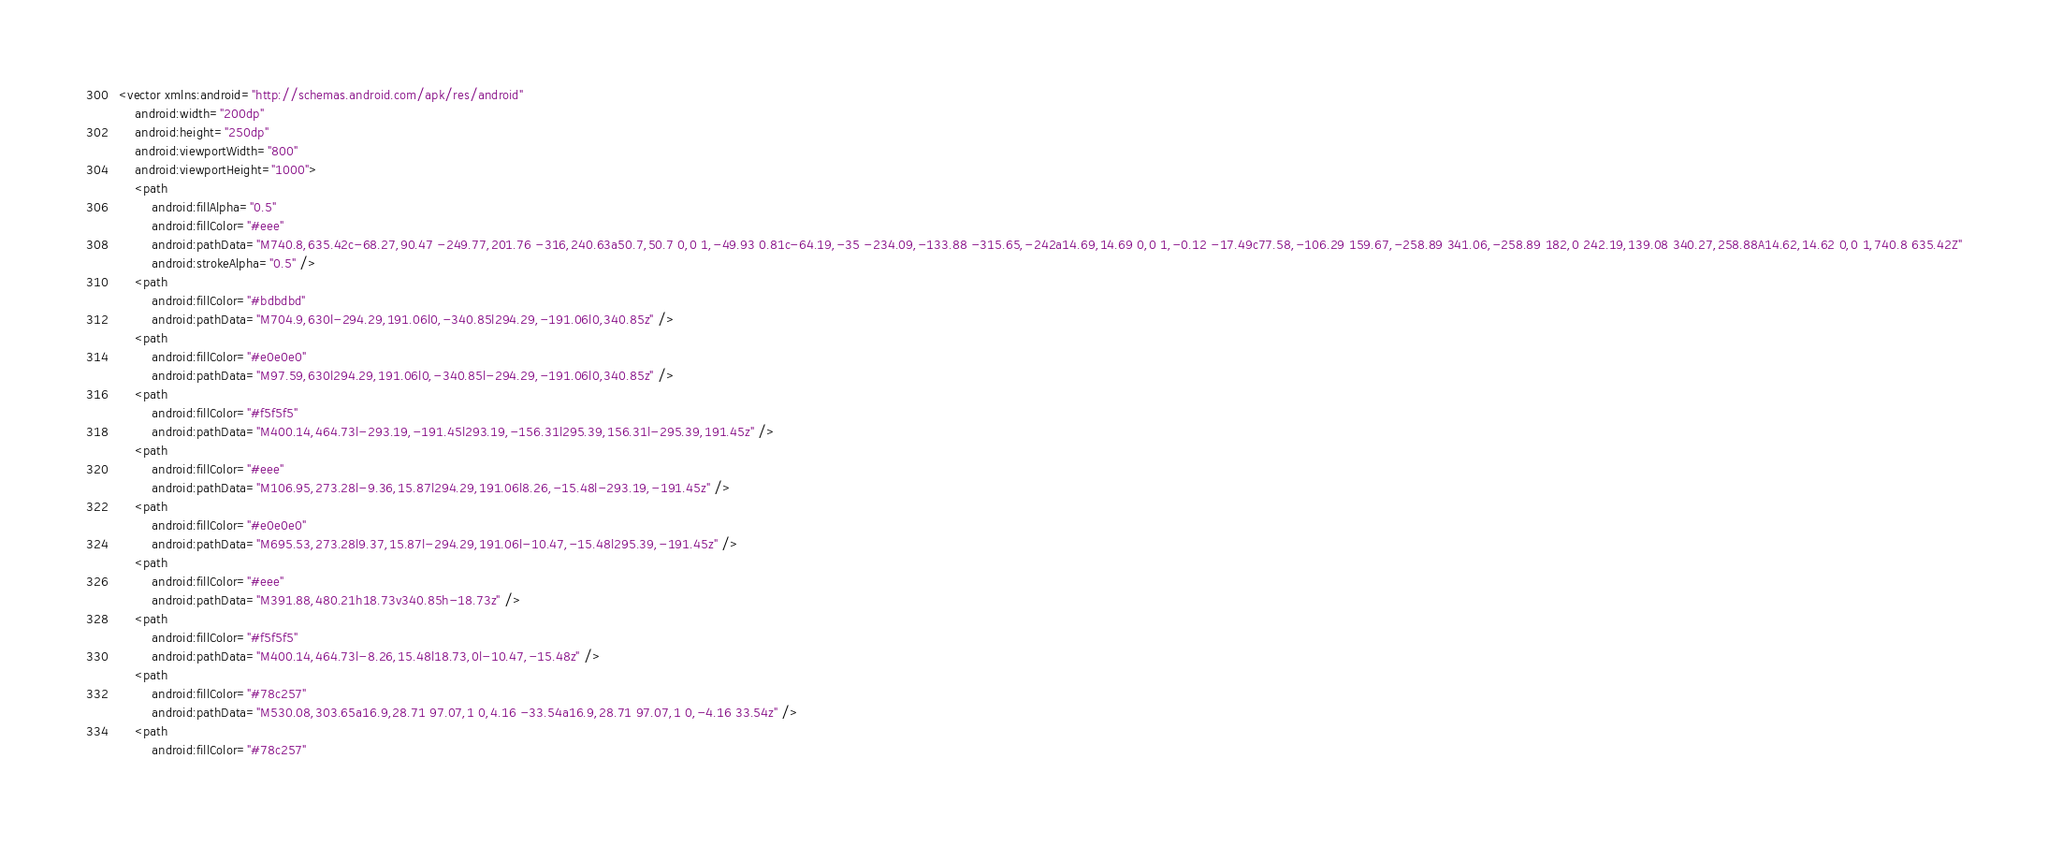<code> <loc_0><loc_0><loc_500><loc_500><_XML_>
<vector xmlns:android="http://schemas.android.com/apk/res/android"
    android:width="200dp"
    android:height="250dp"
    android:viewportWidth="800"
    android:viewportHeight="1000">
    <path
        android:fillAlpha="0.5"
        android:fillColor="#eee"
        android:pathData="M740.8,635.42c-68.27,90.47 -249.77,201.76 -316,240.63a50.7,50.7 0,0 1,-49.93 0.81c-64.19,-35 -234.09,-133.88 -315.65,-242a14.69,14.69 0,0 1,-0.12 -17.49c77.58,-106.29 159.67,-258.89 341.06,-258.89 182,0 242.19,139.08 340.27,258.88A14.62,14.62 0,0 1,740.8 635.42Z"
        android:strokeAlpha="0.5" />
    <path
        android:fillColor="#bdbdbd"
        android:pathData="M704.9,630l-294.29,191.06l0,-340.85l294.29,-191.06l0,340.85z" />
    <path
        android:fillColor="#e0e0e0"
        android:pathData="M97.59,630l294.29,191.06l0,-340.85l-294.29,-191.06l0,340.85z" />
    <path
        android:fillColor="#f5f5f5"
        android:pathData="M400.14,464.73l-293.19,-191.45l293.19,-156.31l295.39,156.31l-295.39,191.45z" />
    <path
        android:fillColor="#eee"
        android:pathData="M106.95,273.28l-9.36,15.87l294.29,191.06l8.26,-15.48l-293.19,-191.45z" />
    <path
        android:fillColor="#e0e0e0"
        android:pathData="M695.53,273.28l9.37,15.87l-294.29,191.06l-10.47,-15.48l295.39,-191.45z" />
    <path
        android:fillColor="#eee"
        android:pathData="M391.88,480.21h18.73v340.85h-18.73z" />
    <path
        android:fillColor="#f5f5f5"
        android:pathData="M400.14,464.73l-8.26,15.48l18.73,0l-10.47,-15.48z" />
    <path
        android:fillColor="#78c257"
        android:pathData="M530.08,303.65a16.9,28.71 97.07,1 0,4.16 -33.54a16.9,28.71 97.07,1 0,-4.16 33.54z" />
    <path
        android:fillColor="#78c257"</code> 